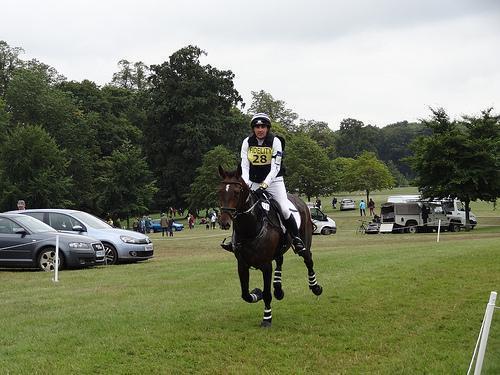How many blue cars are there?
Give a very brief answer. 2. 